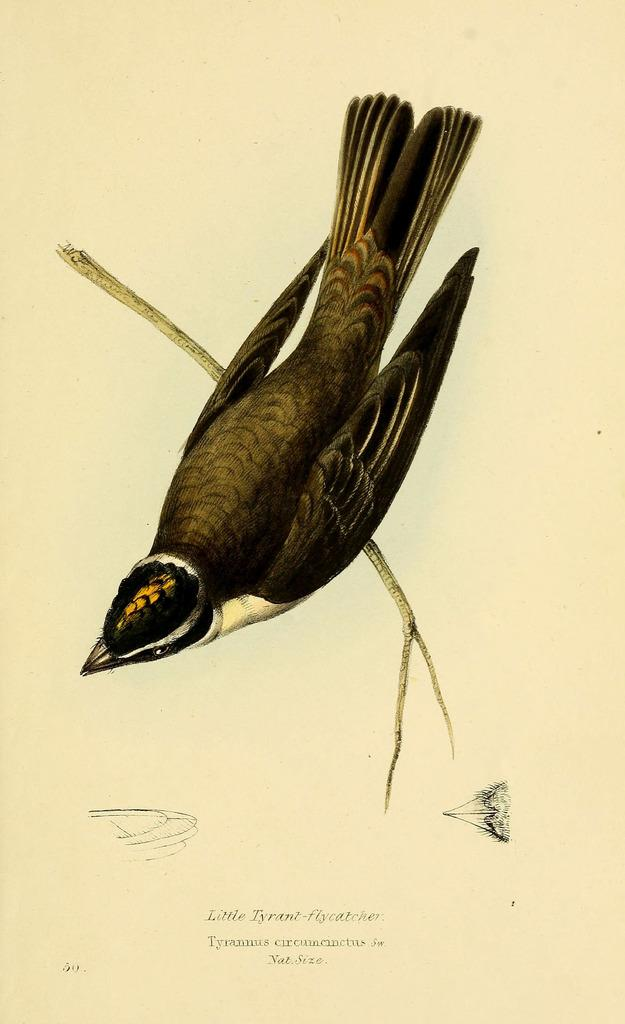What is depicted in the drawing in the image? There is a drawing of a bird in the image. Where is the bird located in the drawing? The bird is sitting on a branch in the drawing. What is the branch a part of? The branch is part of a tree. What type of match is the bird holding in the image? There is no match present in the image; it is a drawing of a bird sitting on a branch. 